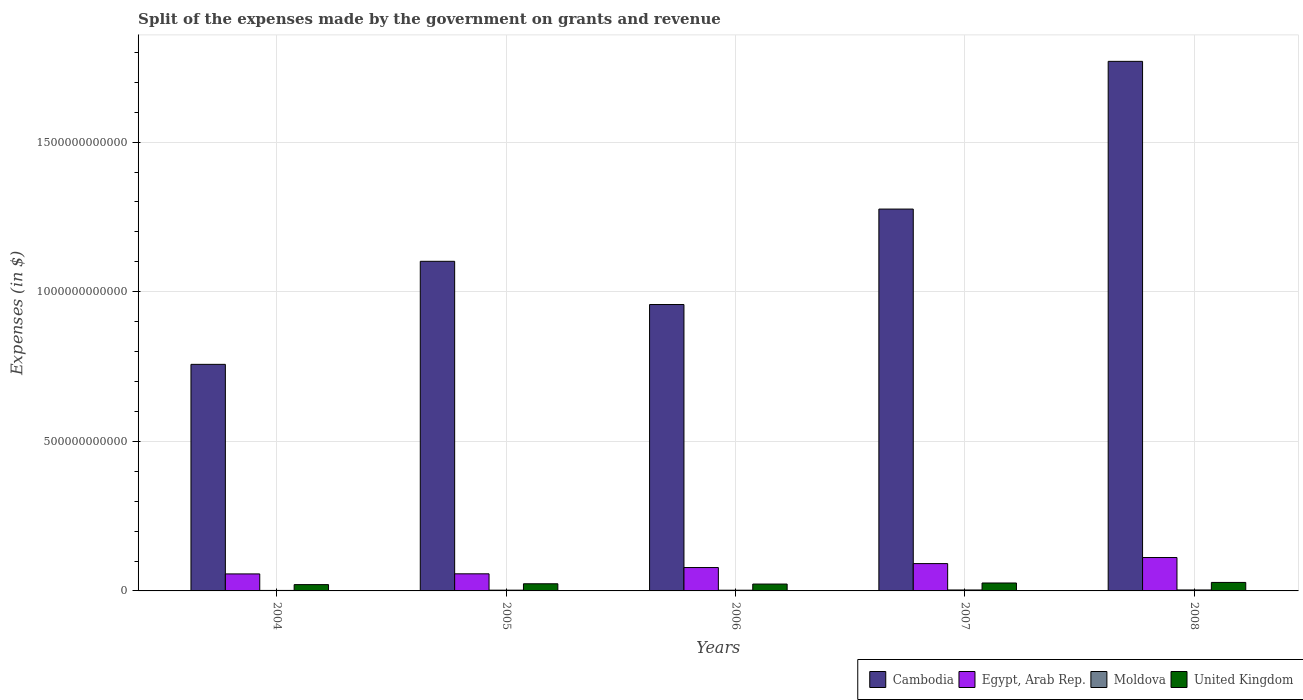How many different coloured bars are there?
Ensure brevity in your answer.  4. What is the label of the 4th group of bars from the left?
Your answer should be compact. 2007. In how many cases, is the number of bars for a given year not equal to the number of legend labels?
Offer a very short reply. 0. What is the expenses made by the government on grants and revenue in Egypt, Arab Rep. in 2007?
Your response must be concise. 9.13e+1. Across all years, what is the maximum expenses made by the government on grants and revenue in Moldova?
Make the answer very short. 3.19e+09. Across all years, what is the minimum expenses made by the government on grants and revenue in Egypt, Arab Rep.?
Your response must be concise. 5.68e+1. In which year was the expenses made by the government on grants and revenue in Cambodia maximum?
Provide a short and direct response. 2008. In which year was the expenses made by the government on grants and revenue in Egypt, Arab Rep. minimum?
Offer a very short reply. 2004. What is the total expenses made by the government on grants and revenue in United Kingdom in the graph?
Ensure brevity in your answer.  1.23e+11. What is the difference between the expenses made by the government on grants and revenue in Cambodia in 2004 and that in 2008?
Your response must be concise. -1.01e+12. What is the difference between the expenses made by the government on grants and revenue in Moldova in 2005 and the expenses made by the government on grants and revenue in United Kingdom in 2004?
Your response must be concise. -1.85e+1. What is the average expenses made by the government on grants and revenue in Egypt, Arab Rep. per year?
Offer a terse response. 7.90e+1. In the year 2008, what is the difference between the expenses made by the government on grants and revenue in Moldova and expenses made by the government on grants and revenue in Cambodia?
Give a very brief answer. -1.77e+12. What is the ratio of the expenses made by the government on grants and revenue in Egypt, Arab Rep. in 2004 to that in 2007?
Your answer should be very brief. 0.62. Is the expenses made by the government on grants and revenue in Moldova in 2004 less than that in 2008?
Provide a short and direct response. Yes. What is the difference between the highest and the second highest expenses made by the government on grants and revenue in Egypt, Arab Rep.?
Your answer should be very brief. 2.03e+1. What is the difference between the highest and the lowest expenses made by the government on grants and revenue in United Kingdom?
Ensure brevity in your answer.  7.30e+09. In how many years, is the expenses made by the government on grants and revenue in United Kingdom greater than the average expenses made by the government on grants and revenue in United Kingdom taken over all years?
Provide a succinct answer. 2. Is the sum of the expenses made by the government on grants and revenue in Egypt, Arab Rep. in 2006 and 2007 greater than the maximum expenses made by the government on grants and revenue in United Kingdom across all years?
Your response must be concise. Yes. What does the 3rd bar from the left in 2004 represents?
Your answer should be very brief. Moldova. What does the 3rd bar from the right in 2004 represents?
Offer a very short reply. Egypt, Arab Rep. Is it the case that in every year, the sum of the expenses made by the government on grants and revenue in Egypt, Arab Rep. and expenses made by the government on grants and revenue in Moldova is greater than the expenses made by the government on grants and revenue in United Kingdom?
Offer a terse response. Yes. What is the difference between two consecutive major ticks on the Y-axis?
Your answer should be compact. 5.00e+11. Are the values on the major ticks of Y-axis written in scientific E-notation?
Keep it short and to the point. No. What is the title of the graph?
Provide a succinct answer. Split of the expenses made by the government on grants and revenue. What is the label or title of the X-axis?
Your answer should be very brief. Years. What is the label or title of the Y-axis?
Provide a succinct answer. Expenses (in $). What is the Expenses (in $) in Cambodia in 2004?
Make the answer very short. 7.57e+11. What is the Expenses (in $) in Egypt, Arab Rep. in 2004?
Your response must be concise. 5.68e+1. What is the Expenses (in $) of Moldova in 2004?
Offer a terse response. 1.64e+09. What is the Expenses (in $) of United Kingdom in 2004?
Provide a short and direct response. 2.11e+1. What is the Expenses (in $) of Cambodia in 2005?
Keep it short and to the point. 1.10e+12. What is the Expenses (in $) in Egypt, Arab Rep. in 2005?
Provide a short and direct response. 5.72e+1. What is the Expenses (in $) in Moldova in 2005?
Ensure brevity in your answer.  2.54e+09. What is the Expenses (in $) of United Kingdom in 2005?
Your response must be concise. 2.39e+1. What is the Expenses (in $) in Cambodia in 2006?
Offer a very short reply. 9.57e+11. What is the Expenses (in $) in Egypt, Arab Rep. in 2006?
Make the answer very short. 7.82e+1. What is the Expenses (in $) in Moldova in 2006?
Provide a short and direct response. 2.36e+09. What is the Expenses (in $) in United Kingdom in 2006?
Give a very brief answer. 2.29e+1. What is the Expenses (in $) of Cambodia in 2007?
Offer a terse response. 1.28e+12. What is the Expenses (in $) in Egypt, Arab Rep. in 2007?
Ensure brevity in your answer.  9.13e+1. What is the Expenses (in $) of Moldova in 2007?
Your response must be concise. 3.16e+09. What is the Expenses (in $) in United Kingdom in 2007?
Your answer should be very brief. 2.65e+1. What is the Expenses (in $) in Cambodia in 2008?
Ensure brevity in your answer.  1.77e+12. What is the Expenses (in $) in Egypt, Arab Rep. in 2008?
Ensure brevity in your answer.  1.12e+11. What is the Expenses (in $) in Moldova in 2008?
Offer a very short reply. 3.19e+09. What is the Expenses (in $) of United Kingdom in 2008?
Offer a terse response. 2.84e+1. Across all years, what is the maximum Expenses (in $) in Cambodia?
Provide a succinct answer. 1.77e+12. Across all years, what is the maximum Expenses (in $) in Egypt, Arab Rep.?
Your answer should be compact. 1.12e+11. Across all years, what is the maximum Expenses (in $) in Moldova?
Make the answer very short. 3.19e+09. Across all years, what is the maximum Expenses (in $) in United Kingdom?
Your answer should be very brief. 2.84e+1. Across all years, what is the minimum Expenses (in $) of Cambodia?
Your response must be concise. 7.57e+11. Across all years, what is the minimum Expenses (in $) in Egypt, Arab Rep.?
Your response must be concise. 5.68e+1. Across all years, what is the minimum Expenses (in $) in Moldova?
Keep it short and to the point. 1.64e+09. Across all years, what is the minimum Expenses (in $) in United Kingdom?
Offer a very short reply. 2.11e+1. What is the total Expenses (in $) in Cambodia in the graph?
Keep it short and to the point. 5.86e+12. What is the total Expenses (in $) in Egypt, Arab Rep. in the graph?
Provide a succinct answer. 3.95e+11. What is the total Expenses (in $) in Moldova in the graph?
Offer a terse response. 1.29e+1. What is the total Expenses (in $) in United Kingdom in the graph?
Your answer should be very brief. 1.23e+11. What is the difference between the Expenses (in $) in Cambodia in 2004 and that in 2005?
Give a very brief answer. -3.44e+11. What is the difference between the Expenses (in $) in Egypt, Arab Rep. in 2004 and that in 2005?
Offer a terse response. -3.48e+08. What is the difference between the Expenses (in $) of Moldova in 2004 and that in 2005?
Keep it short and to the point. -9.00e+08. What is the difference between the Expenses (in $) of United Kingdom in 2004 and that in 2005?
Your answer should be compact. -2.81e+09. What is the difference between the Expenses (in $) in Cambodia in 2004 and that in 2006?
Give a very brief answer. -2.00e+11. What is the difference between the Expenses (in $) in Egypt, Arab Rep. in 2004 and that in 2006?
Make the answer very short. -2.13e+1. What is the difference between the Expenses (in $) in Moldova in 2004 and that in 2006?
Offer a terse response. -7.19e+08. What is the difference between the Expenses (in $) in United Kingdom in 2004 and that in 2006?
Your answer should be very brief. -1.87e+09. What is the difference between the Expenses (in $) of Cambodia in 2004 and that in 2007?
Offer a terse response. -5.19e+11. What is the difference between the Expenses (in $) of Egypt, Arab Rep. in 2004 and that in 2007?
Provide a succinct answer. -3.45e+1. What is the difference between the Expenses (in $) in Moldova in 2004 and that in 2007?
Provide a short and direct response. -1.52e+09. What is the difference between the Expenses (in $) in United Kingdom in 2004 and that in 2007?
Your answer should be compact. -5.46e+09. What is the difference between the Expenses (in $) of Cambodia in 2004 and that in 2008?
Make the answer very short. -1.01e+12. What is the difference between the Expenses (in $) in Egypt, Arab Rep. in 2004 and that in 2008?
Your answer should be very brief. -5.48e+1. What is the difference between the Expenses (in $) of Moldova in 2004 and that in 2008?
Keep it short and to the point. -1.55e+09. What is the difference between the Expenses (in $) in United Kingdom in 2004 and that in 2008?
Provide a short and direct response. -7.30e+09. What is the difference between the Expenses (in $) in Cambodia in 2005 and that in 2006?
Keep it short and to the point. 1.44e+11. What is the difference between the Expenses (in $) of Egypt, Arab Rep. in 2005 and that in 2006?
Your answer should be compact. -2.10e+1. What is the difference between the Expenses (in $) in Moldova in 2005 and that in 2006?
Give a very brief answer. 1.80e+08. What is the difference between the Expenses (in $) of United Kingdom in 2005 and that in 2006?
Your answer should be compact. 9.37e+08. What is the difference between the Expenses (in $) in Cambodia in 2005 and that in 2007?
Provide a succinct answer. -1.75e+11. What is the difference between the Expenses (in $) in Egypt, Arab Rep. in 2005 and that in 2007?
Your answer should be very brief. -3.42e+1. What is the difference between the Expenses (in $) in Moldova in 2005 and that in 2007?
Your response must be concise. -6.21e+08. What is the difference between the Expenses (in $) of United Kingdom in 2005 and that in 2007?
Provide a succinct answer. -2.66e+09. What is the difference between the Expenses (in $) in Cambodia in 2005 and that in 2008?
Give a very brief answer. -6.68e+11. What is the difference between the Expenses (in $) of Egypt, Arab Rep. in 2005 and that in 2008?
Your answer should be very brief. -5.45e+1. What is the difference between the Expenses (in $) of Moldova in 2005 and that in 2008?
Your answer should be very brief. -6.55e+08. What is the difference between the Expenses (in $) of United Kingdom in 2005 and that in 2008?
Keep it short and to the point. -4.50e+09. What is the difference between the Expenses (in $) in Cambodia in 2006 and that in 2007?
Ensure brevity in your answer.  -3.19e+11. What is the difference between the Expenses (in $) of Egypt, Arab Rep. in 2006 and that in 2007?
Your answer should be compact. -1.32e+1. What is the difference between the Expenses (in $) in Moldova in 2006 and that in 2007?
Offer a terse response. -8.02e+08. What is the difference between the Expenses (in $) of United Kingdom in 2006 and that in 2007?
Offer a very short reply. -3.59e+09. What is the difference between the Expenses (in $) of Cambodia in 2006 and that in 2008?
Your response must be concise. -8.13e+11. What is the difference between the Expenses (in $) in Egypt, Arab Rep. in 2006 and that in 2008?
Ensure brevity in your answer.  -3.35e+1. What is the difference between the Expenses (in $) of Moldova in 2006 and that in 2008?
Provide a succinct answer. -8.36e+08. What is the difference between the Expenses (in $) of United Kingdom in 2006 and that in 2008?
Offer a very short reply. -5.43e+09. What is the difference between the Expenses (in $) in Cambodia in 2007 and that in 2008?
Provide a short and direct response. -4.94e+11. What is the difference between the Expenses (in $) in Egypt, Arab Rep. in 2007 and that in 2008?
Offer a very short reply. -2.03e+1. What is the difference between the Expenses (in $) of Moldova in 2007 and that in 2008?
Keep it short and to the point. -3.39e+07. What is the difference between the Expenses (in $) of United Kingdom in 2007 and that in 2008?
Offer a terse response. -1.84e+09. What is the difference between the Expenses (in $) in Cambodia in 2004 and the Expenses (in $) in Egypt, Arab Rep. in 2005?
Your response must be concise. 7.00e+11. What is the difference between the Expenses (in $) of Cambodia in 2004 and the Expenses (in $) of Moldova in 2005?
Provide a short and direct response. 7.55e+11. What is the difference between the Expenses (in $) of Cambodia in 2004 and the Expenses (in $) of United Kingdom in 2005?
Provide a short and direct response. 7.33e+11. What is the difference between the Expenses (in $) of Egypt, Arab Rep. in 2004 and the Expenses (in $) of Moldova in 2005?
Make the answer very short. 5.43e+1. What is the difference between the Expenses (in $) in Egypt, Arab Rep. in 2004 and the Expenses (in $) in United Kingdom in 2005?
Offer a very short reply. 3.30e+1. What is the difference between the Expenses (in $) of Moldova in 2004 and the Expenses (in $) of United Kingdom in 2005?
Your answer should be very brief. -2.22e+1. What is the difference between the Expenses (in $) of Cambodia in 2004 and the Expenses (in $) of Egypt, Arab Rep. in 2006?
Provide a short and direct response. 6.79e+11. What is the difference between the Expenses (in $) in Cambodia in 2004 and the Expenses (in $) in Moldova in 2006?
Offer a terse response. 7.55e+11. What is the difference between the Expenses (in $) in Cambodia in 2004 and the Expenses (in $) in United Kingdom in 2006?
Make the answer very short. 7.34e+11. What is the difference between the Expenses (in $) in Egypt, Arab Rep. in 2004 and the Expenses (in $) in Moldova in 2006?
Provide a succinct answer. 5.45e+1. What is the difference between the Expenses (in $) in Egypt, Arab Rep. in 2004 and the Expenses (in $) in United Kingdom in 2006?
Your answer should be very brief. 3.39e+1. What is the difference between the Expenses (in $) of Moldova in 2004 and the Expenses (in $) of United Kingdom in 2006?
Make the answer very short. -2.13e+1. What is the difference between the Expenses (in $) in Cambodia in 2004 and the Expenses (in $) in Egypt, Arab Rep. in 2007?
Provide a succinct answer. 6.66e+11. What is the difference between the Expenses (in $) in Cambodia in 2004 and the Expenses (in $) in Moldova in 2007?
Keep it short and to the point. 7.54e+11. What is the difference between the Expenses (in $) in Cambodia in 2004 and the Expenses (in $) in United Kingdom in 2007?
Offer a very short reply. 7.31e+11. What is the difference between the Expenses (in $) in Egypt, Arab Rep. in 2004 and the Expenses (in $) in Moldova in 2007?
Ensure brevity in your answer.  5.37e+1. What is the difference between the Expenses (in $) in Egypt, Arab Rep. in 2004 and the Expenses (in $) in United Kingdom in 2007?
Provide a succinct answer. 3.03e+1. What is the difference between the Expenses (in $) in Moldova in 2004 and the Expenses (in $) in United Kingdom in 2007?
Your response must be concise. -2.49e+1. What is the difference between the Expenses (in $) of Cambodia in 2004 and the Expenses (in $) of Egypt, Arab Rep. in 2008?
Provide a succinct answer. 6.46e+11. What is the difference between the Expenses (in $) in Cambodia in 2004 and the Expenses (in $) in Moldova in 2008?
Give a very brief answer. 7.54e+11. What is the difference between the Expenses (in $) of Cambodia in 2004 and the Expenses (in $) of United Kingdom in 2008?
Give a very brief answer. 7.29e+11. What is the difference between the Expenses (in $) of Egypt, Arab Rep. in 2004 and the Expenses (in $) of Moldova in 2008?
Provide a short and direct response. 5.36e+1. What is the difference between the Expenses (in $) in Egypt, Arab Rep. in 2004 and the Expenses (in $) in United Kingdom in 2008?
Provide a succinct answer. 2.85e+1. What is the difference between the Expenses (in $) of Moldova in 2004 and the Expenses (in $) of United Kingdom in 2008?
Make the answer very short. -2.67e+1. What is the difference between the Expenses (in $) in Cambodia in 2005 and the Expenses (in $) in Egypt, Arab Rep. in 2006?
Your answer should be compact. 1.02e+12. What is the difference between the Expenses (in $) in Cambodia in 2005 and the Expenses (in $) in Moldova in 2006?
Your answer should be compact. 1.10e+12. What is the difference between the Expenses (in $) of Cambodia in 2005 and the Expenses (in $) of United Kingdom in 2006?
Provide a succinct answer. 1.08e+12. What is the difference between the Expenses (in $) in Egypt, Arab Rep. in 2005 and the Expenses (in $) in Moldova in 2006?
Provide a succinct answer. 5.48e+1. What is the difference between the Expenses (in $) in Egypt, Arab Rep. in 2005 and the Expenses (in $) in United Kingdom in 2006?
Provide a succinct answer. 3.42e+1. What is the difference between the Expenses (in $) of Moldova in 2005 and the Expenses (in $) of United Kingdom in 2006?
Your response must be concise. -2.04e+1. What is the difference between the Expenses (in $) of Cambodia in 2005 and the Expenses (in $) of Egypt, Arab Rep. in 2007?
Keep it short and to the point. 1.01e+12. What is the difference between the Expenses (in $) in Cambodia in 2005 and the Expenses (in $) in Moldova in 2007?
Offer a very short reply. 1.10e+12. What is the difference between the Expenses (in $) of Cambodia in 2005 and the Expenses (in $) of United Kingdom in 2007?
Offer a very short reply. 1.08e+12. What is the difference between the Expenses (in $) of Egypt, Arab Rep. in 2005 and the Expenses (in $) of Moldova in 2007?
Make the answer very short. 5.40e+1. What is the difference between the Expenses (in $) of Egypt, Arab Rep. in 2005 and the Expenses (in $) of United Kingdom in 2007?
Offer a terse response. 3.06e+1. What is the difference between the Expenses (in $) in Moldova in 2005 and the Expenses (in $) in United Kingdom in 2007?
Provide a short and direct response. -2.40e+1. What is the difference between the Expenses (in $) of Cambodia in 2005 and the Expenses (in $) of Egypt, Arab Rep. in 2008?
Give a very brief answer. 9.90e+11. What is the difference between the Expenses (in $) in Cambodia in 2005 and the Expenses (in $) in Moldova in 2008?
Make the answer very short. 1.10e+12. What is the difference between the Expenses (in $) in Cambodia in 2005 and the Expenses (in $) in United Kingdom in 2008?
Keep it short and to the point. 1.07e+12. What is the difference between the Expenses (in $) in Egypt, Arab Rep. in 2005 and the Expenses (in $) in Moldova in 2008?
Your answer should be compact. 5.40e+1. What is the difference between the Expenses (in $) of Egypt, Arab Rep. in 2005 and the Expenses (in $) of United Kingdom in 2008?
Ensure brevity in your answer.  2.88e+1. What is the difference between the Expenses (in $) of Moldova in 2005 and the Expenses (in $) of United Kingdom in 2008?
Provide a succinct answer. -2.58e+1. What is the difference between the Expenses (in $) in Cambodia in 2006 and the Expenses (in $) in Egypt, Arab Rep. in 2007?
Make the answer very short. 8.66e+11. What is the difference between the Expenses (in $) of Cambodia in 2006 and the Expenses (in $) of Moldova in 2007?
Offer a terse response. 9.54e+11. What is the difference between the Expenses (in $) of Cambodia in 2006 and the Expenses (in $) of United Kingdom in 2007?
Keep it short and to the point. 9.31e+11. What is the difference between the Expenses (in $) of Egypt, Arab Rep. in 2006 and the Expenses (in $) of Moldova in 2007?
Provide a succinct answer. 7.50e+1. What is the difference between the Expenses (in $) of Egypt, Arab Rep. in 2006 and the Expenses (in $) of United Kingdom in 2007?
Your answer should be very brief. 5.16e+1. What is the difference between the Expenses (in $) in Moldova in 2006 and the Expenses (in $) in United Kingdom in 2007?
Your answer should be compact. -2.42e+1. What is the difference between the Expenses (in $) of Cambodia in 2006 and the Expenses (in $) of Egypt, Arab Rep. in 2008?
Your answer should be compact. 8.46e+11. What is the difference between the Expenses (in $) of Cambodia in 2006 and the Expenses (in $) of Moldova in 2008?
Make the answer very short. 9.54e+11. What is the difference between the Expenses (in $) of Cambodia in 2006 and the Expenses (in $) of United Kingdom in 2008?
Give a very brief answer. 9.29e+11. What is the difference between the Expenses (in $) in Egypt, Arab Rep. in 2006 and the Expenses (in $) in Moldova in 2008?
Keep it short and to the point. 7.50e+1. What is the difference between the Expenses (in $) of Egypt, Arab Rep. in 2006 and the Expenses (in $) of United Kingdom in 2008?
Offer a very short reply. 4.98e+1. What is the difference between the Expenses (in $) in Moldova in 2006 and the Expenses (in $) in United Kingdom in 2008?
Offer a terse response. -2.60e+1. What is the difference between the Expenses (in $) of Cambodia in 2007 and the Expenses (in $) of Egypt, Arab Rep. in 2008?
Offer a very short reply. 1.16e+12. What is the difference between the Expenses (in $) of Cambodia in 2007 and the Expenses (in $) of Moldova in 2008?
Give a very brief answer. 1.27e+12. What is the difference between the Expenses (in $) of Cambodia in 2007 and the Expenses (in $) of United Kingdom in 2008?
Give a very brief answer. 1.25e+12. What is the difference between the Expenses (in $) of Egypt, Arab Rep. in 2007 and the Expenses (in $) of Moldova in 2008?
Provide a short and direct response. 8.81e+1. What is the difference between the Expenses (in $) of Egypt, Arab Rep. in 2007 and the Expenses (in $) of United Kingdom in 2008?
Your answer should be compact. 6.30e+1. What is the difference between the Expenses (in $) in Moldova in 2007 and the Expenses (in $) in United Kingdom in 2008?
Make the answer very short. -2.52e+1. What is the average Expenses (in $) in Cambodia per year?
Offer a terse response. 1.17e+12. What is the average Expenses (in $) in Egypt, Arab Rep. per year?
Offer a terse response. 7.90e+1. What is the average Expenses (in $) of Moldova per year?
Offer a very short reply. 2.58e+09. What is the average Expenses (in $) of United Kingdom per year?
Your answer should be compact. 2.45e+1. In the year 2004, what is the difference between the Expenses (in $) of Cambodia and Expenses (in $) of Egypt, Arab Rep.?
Offer a terse response. 7.00e+11. In the year 2004, what is the difference between the Expenses (in $) in Cambodia and Expenses (in $) in Moldova?
Offer a very short reply. 7.56e+11. In the year 2004, what is the difference between the Expenses (in $) of Cambodia and Expenses (in $) of United Kingdom?
Provide a succinct answer. 7.36e+11. In the year 2004, what is the difference between the Expenses (in $) of Egypt, Arab Rep. and Expenses (in $) of Moldova?
Your answer should be very brief. 5.52e+1. In the year 2004, what is the difference between the Expenses (in $) in Egypt, Arab Rep. and Expenses (in $) in United Kingdom?
Ensure brevity in your answer.  3.58e+1. In the year 2004, what is the difference between the Expenses (in $) in Moldova and Expenses (in $) in United Kingdom?
Provide a succinct answer. -1.94e+1. In the year 2005, what is the difference between the Expenses (in $) of Cambodia and Expenses (in $) of Egypt, Arab Rep.?
Your answer should be very brief. 1.04e+12. In the year 2005, what is the difference between the Expenses (in $) of Cambodia and Expenses (in $) of Moldova?
Provide a succinct answer. 1.10e+12. In the year 2005, what is the difference between the Expenses (in $) of Cambodia and Expenses (in $) of United Kingdom?
Keep it short and to the point. 1.08e+12. In the year 2005, what is the difference between the Expenses (in $) in Egypt, Arab Rep. and Expenses (in $) in Moldova?
Give a very brief answer. 5.46e+1. In the year 2005, what is the difference between the Expenses (in $) of Egypt, Arab Rep. and Expenses (in $) of United Kingdom?
Your answer should be very brief. 3.33e+1. In the year 2005, what is the difference between the Expenses (in $) in Moldova and Expenses (in $) in United Kingdom?
Make the answer very short. -2.13e+1. In the year 2006, what is the difference between the Expenses (in $) of Cambodia and Expenses (in $) of Egypt, Arab Rep.?
Your answer should be very brief. 8.79e+11. In the year 2006, what is the difference between the Expenses (in $) of Cambodia and Expenses (in $) of Moldova?
Your answer should be very brief. 9.55e+11. In the year 2006, what is the difference between the Expenses (in $) of Cambodia and Expenses (in $) of United Kingdom?
Offer a very short reply. 9.34e+11. In the year 2006, what is the difference between the Expenses (in $) in Egypt, Arab Rep. and Expenses (in $) in Moldova?
Provide a succinct answer. 7.58e+1. In the year 2006, what is the difference between the Expenses (in $) in Egypt, Arab Rep. and Expenses (in $) in United Kingdom?
Your answer should be very brief. 5.52e+1. In the year 2006, what is the difference between the Expenses (in $) of Moldova and Expenses (in $) of United Kingdom?
Give a very brief answer. -2.06e+1. In the year 2007, what is the difference between the Expenses (in $) of Cambodia and Expenses (in $) of Egypt, Arab Rep.?
Ensure brevity in your answer.  1.18e+12. In the year 2007, what is the difference between the Expenses (in $) of Cambodia and Expenses (in $) of Moldova?
Provide a short and direct response. 1.27e+12. In the year 2007, what is the difference between the Expenses (in $) of Cambodia and Expenses (in $) of United Kingdom?
Your answer should be very brief. 1.25e+12. In the year 2007, what is the difference between the Expenses (in $) of Egypt, Arab Rep. and Expenses (in $) of Moldova?
Make the answer very short. 8.82e+1. In the year 2007, what is the difference between the Expenses (in $) of Egypt, Arab Rep. and Expenses (in $) of United Kingdom?
Ensure brevity in your answer.  6.48e+1. In the year 2007, what is the difference between the Expenses (in $) of Moldova and Expenses (in $) of United Kingdom?
Offer a very short reply. -2.34e+1. In the year 2008, what is the difference between the Expenses (in $) of Cambodia and Expenses (in $) of Egypt, Arab Rep.?
Keep it short and to the point. 1.66e+12. In the year 2008, what is the difference between the Expenses (in $) of Cambodia and Expenses (in $) of Moldova?
Provide a short and direct response. 1.77e+12. In the year 2008, what is the difference between the Expenses (in $) of Cambodia and Expenses (in $) of United Kingdom?
Your answer should be compact. 1.74e+12. In the year 2008, what is the difference between the Expenses (in $) in Egypt, Arab Rep. and Expenses (in $) in Moldova?
Offer a terse response. 1.08e+11. In the year 2008, what is the difference between the Expenses (in $) of Egypt, Arab Rep. and Expenses (in $) of United Kingdom?
Make the answer very short. 8.33e+1. In the year 2008, what is the difference between the Expenses (in $) in Moldova and Expenses (in $) in United Kingdom?
Give a very brief answer. -2.52e+1. What is the ratio of the Expenses (in $) of Cambodia in 2004 to that in 2005?
Offer a very short reply. 0.69. What is the ratio of the Expenses (in $) of Moldova in 2004 to that in 2005?
Provide a short and direct response. 0.65. What is the ratio of the Expenses (in $) of United Kingdom in 2004 to that in 2005?
Give a very brief answer. 0.88. What is the ratio of the Expenses (in $) in Cambodia in 2004 to that in 2006?
Provide a succinct answer. 0.79. What is the ratio of the Expenses (in $) in Egypt, Arab Rep. in 2004 to that in 2006?
Ensure brevity in your answer.  0.73. What is the ratio of the Expenses (in $) of Moldova in 2004 to that in 2006?
Offer a terse response. 0.7. What is the ratio of the Expenses (in $) in United Kingdom in 2004 to that in 2006?
Your response must be concise. 0.92. What is the ratio of the Expenses (in $) of Cambodia in 2004 to that in 2007?
Your answer should be very brief. 0.59. What is the ratio of the Expenses (in $) in Egypt, Arab Rep. in 2004 to that in 2007?
Your answer should be very brief. 0.62. What is the ratio of the Expenses (in $) of Moldova in 2004 to that in 2007?
Give a very brief answer. 0.52. What is the ratio of the Expenses (in $) of United Kingdom in 2004 to that in 2007?
Your response must be concise. 0.79. What is the ratio of the Expenses (in $) in Cambodia in 2004 to that in 2008?
Make the answer very short. 0.43. What is the ratio of the Expenses (in $) of Egypt, Arab Rep. in 2004 to that in 2008?
Offer a terse response. 0.51. What is the ratio of the Expenses (in $) in Moldova in 2004 to that in 2008?
Make the answer very short. 0.51. What is the ratio of the Expenses (in $) of United Kingdom in 2004 to that in 2008?
Your answer should be compact. 0.74. What is the ratio of the Expenses (in $) in Cambodia in 2005 to that in 2006?
Your answer should be compact. 1.15. What is the ratio of the Expenses (in $) in Egypt, Arab Rep. in 2005 to that in 2006?
Your answer should be very brief. 0.73. What is the ratio of the Expenses (in $) of Moldova in 2005 to that in 2006?
Ensure brevity in your answer.  1.08. What is the ratio of the Expenses (in $) in United Kingdom in 2005 to that in 2006?
Provide a succinct answer. 1.04. What is the ratio of the Expenses (in $) of Cambodia in 2005 to that in 2007?
Make the answer very short. 0.86. What is the ratio of the Expenses (in $) of Egypt, Arab Rep. in 2005 to that in 2007?
Keep it short and to the point. 0.63. What is the ratio of the Expenses (in $) of Moldova in 2005 to that in 2007?
Ensure brevity in your answer.  0.8. What is the ratio of the Expenses (in $) of United Kingdom in 2005 to that in 2007?
Offer a very short reply. 0.9. What is the ratio of the Expenses (in $) of Cambodia in 2005 to that in 2008?
Provide a short and direct response. 0.62. What is the ratio of the Expenses (in $) of Egypt, Arab Rep. in 2005 to that in 2008?
Your answer should be very brief. 0.51. What is the ratio of the Expenses (in $) in Moldova in 2005 to that in 2008?
Offer a terse response. 0.79. What is the ratio of the Expenses (in $) of United Kingdom in 2005 to that in 2008?
Provide a short and direct response. 0.84. What is the ratio of the Expenses (in $) of Egypt, Arab Rep. in 2006 to that in 2007?
Keep it short and to the point. 0.86. What is the ratio of the Expenses (in $) in Moldova in 2006 to that in 2007?
Your answer should be compact. 0.75. What is the ratio of the Expenses (in $) in United Kingdom in 2006 to that in 2007?
Give a very brief answer. 0.86. What is the ratio of the Expenses (in $) of Cambodia in 2006 to that in 2008?
Keep it short and to the point. 0.54. What is the ratio of the Expenses (in $) of Egypt, Arab Rep. in 2006 to that in 2008?
Offer a very short reply. 0.7. What is the ratio of the Expenses (in $) of Moldova in 2006 to that in 2008?
Your answer should be compact. 0.74. What is the ratio of the Expenses (in $) in United Kingdom in 2006 to that in 2008?
Your answer should be very brief. 0.81. What is the ratio of the Expenses (in $) of Cambodia in 2007 to that in 2008?
Ensure brevity in your answer.  0.72. What is the ratio of the Expenses (in $) of Egypt, Arab Rep. in 2007 to that in 2008?
Keep it short and to the point. 0.82. What is the ratio of the Expenses (in $) of United Kingdom in 2007 to that in 2008?
Make the answer very short. 0.94. What is the difference between the highest and the second highest Expenses (in $) in Cambodia?
Provide a short and direct response. 4.94e+11. What is the difference between the highest and the second highest Expenses (in $) in Egypt, Arab Rep.?
Your answer should be compact. 2.03e+1. What is the difference between the highest and the second highest Expenses (in $) of Moldova?
Your answer should be very brief. 3.39e+07. What is the difference between the highest and the second highest Expenses (in $) in United Kingdom?
Your answer should be compact. 1.84e+09. What is the difference between the highest and the lowest Expenses (in $) of Cambodia?
Your answer should be very brief. 1.01e+12. What is the difference between the highest and the lowest Expenses (in $) in Egypt, Arab Rep.?
Your response must be concise. 5.48e+1. What is the difference between the highest and the lowest Expenses (in $) of Moldova?
Ensure brevity in your answer.  1.55e+09. What is the difference between the highest and the lowest Expenses (in $) of United Kingdom?
Offer a terse response. 7.30e+09. 